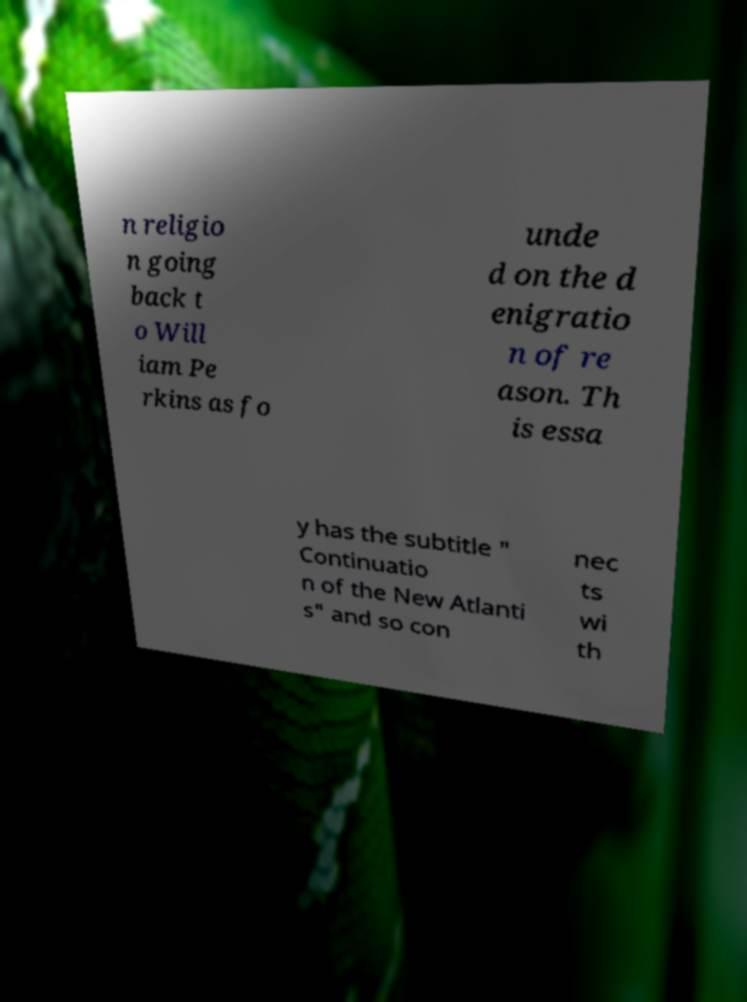I need the written content from this picture converted into text. Can you do that? n religio n going back t o Will iam Pe rkins as fo unde d on the d enigratio n of re ason. Th is essa y has the subtitle " Continuatio n of the New Atlanti s" and so con nec ts wi th 